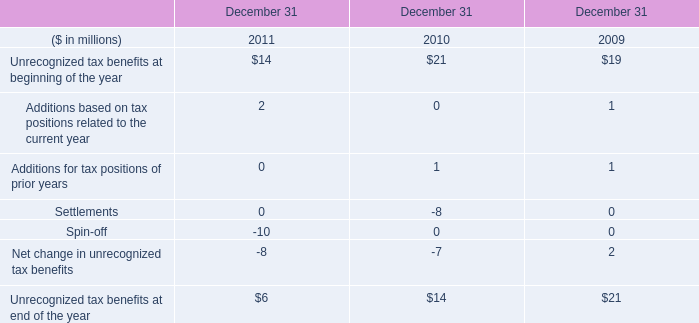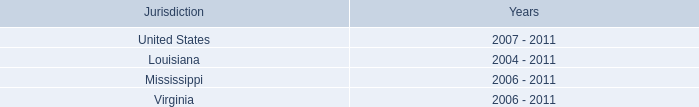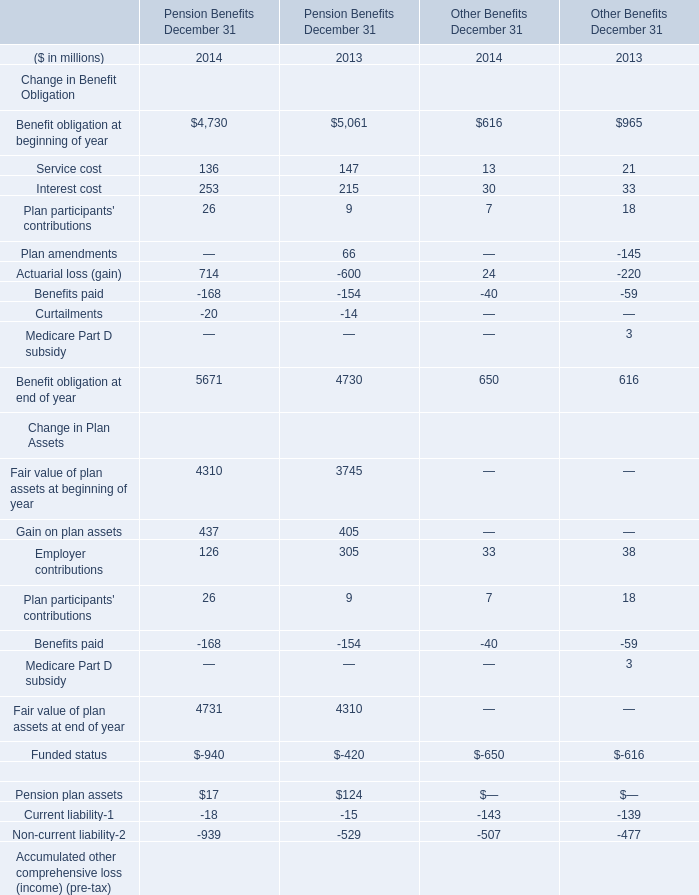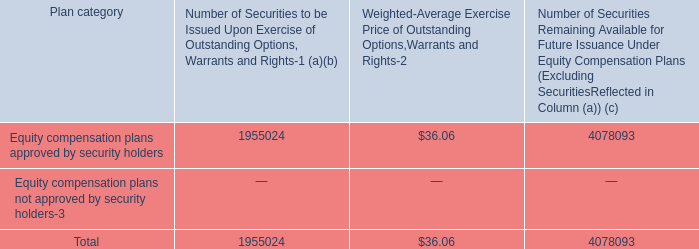what portion of equity compensation plan is to be issued upon exercise of outstanding options warrants and rights? 
Computations: (1955024 / (1955024 + 4078093))
Answer: 0.32405. 